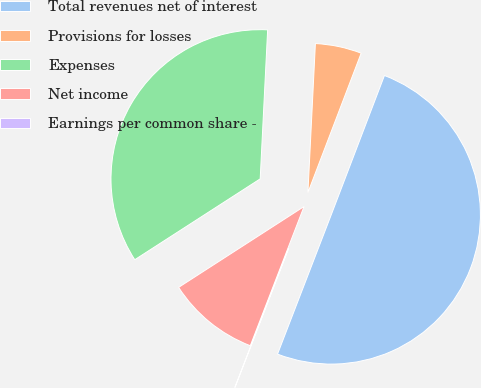Convert chart to OTSL. <chart><loc_0><loc_0><loc_500><loc_500><pie_chart><fcel>Total revenues net of interest<fcel>Provisions for losses<fcel>Expenses<fcel>Net income<fcel>Earnings per common share -<nl><fcel>50.05%<fcel>5.01%<fcel>34.91%<fcel>10.02%<fcel>0.01%<nl></chart> 